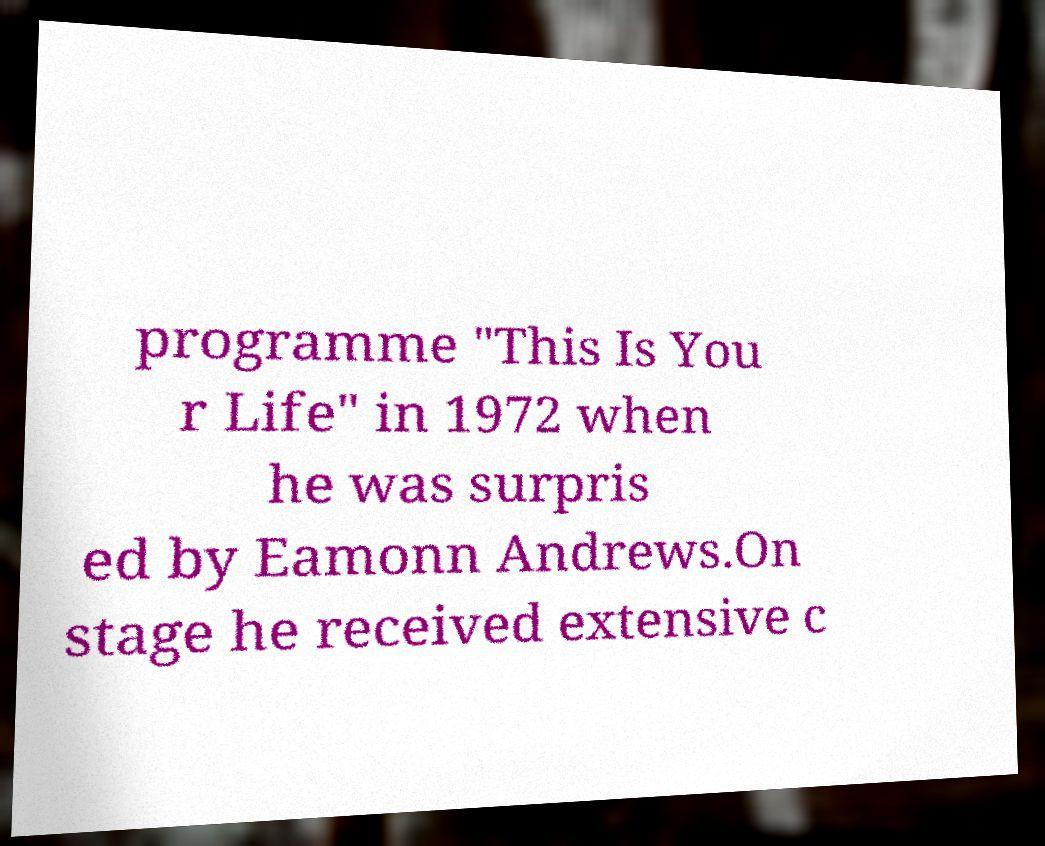Can you read and provide the text displayed in the image?This photo seems to have some interesting text. Can you extract and type it out for me? programme "This Is You r Life" in 1972 when he was surpris ed by Eamonn Andrews.On stage he received extensive c 